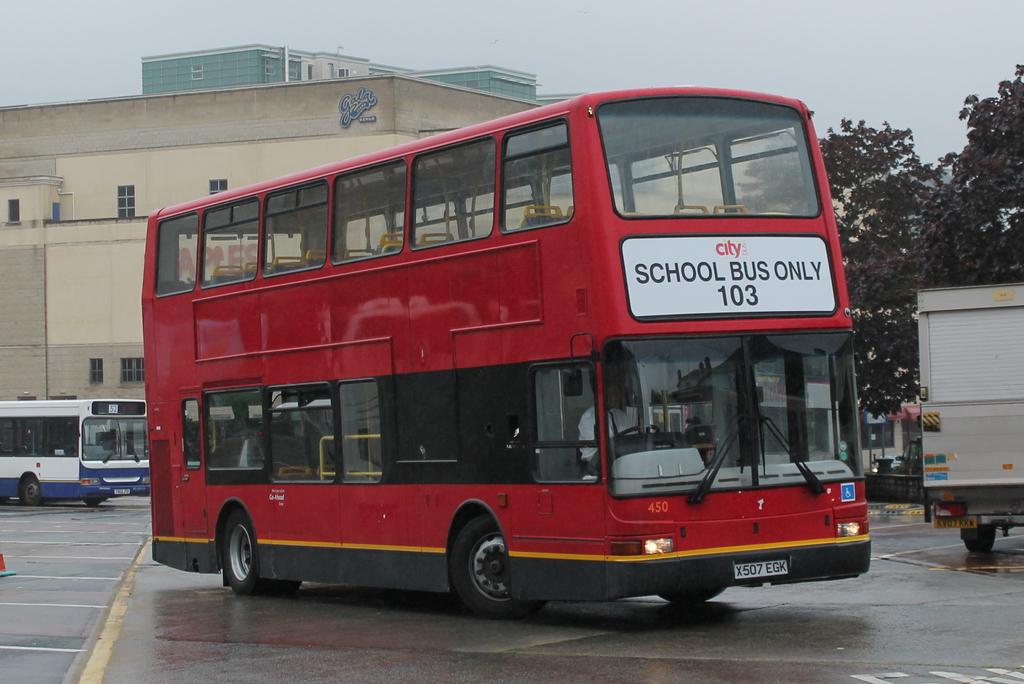What kind of bus is it?
Provide a succinct answer. School. 